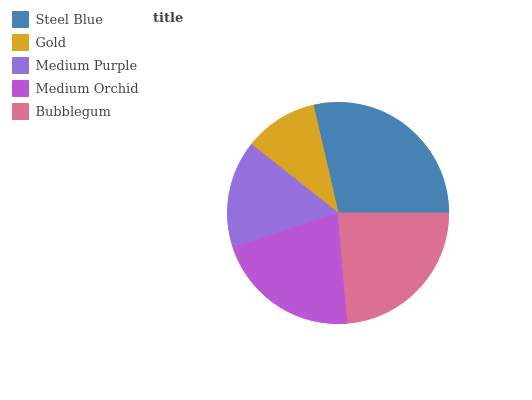Is Gold the minimum?
Answer yes or no. Yes. Is Steel Blue the maximum?
Answer yes or no. Yes. Is Medium Purple the minimum?
Answer yes or no. No. Is Medium Purple the maximum?
Answer yes or no. No. Is Medium Purple greater than Gold?
Answer yes or no. Yes. Is Gold less than Medium Purple?
Answer yes or no. Yes. Is Gold greater than Medium Purple?
Answer yes or no. No. Is Medium Purple less than Gold?
Answer yes or no. No. Is Medium Orchid the high median?
Answer yes or no. Yes. Is Medium Orchid the low median?
Answer yes or no. Yes. Is Medium Purple the high median?
Answer yes or no. No. Is Steel Blue the low median?
Answer yes or no. No. 